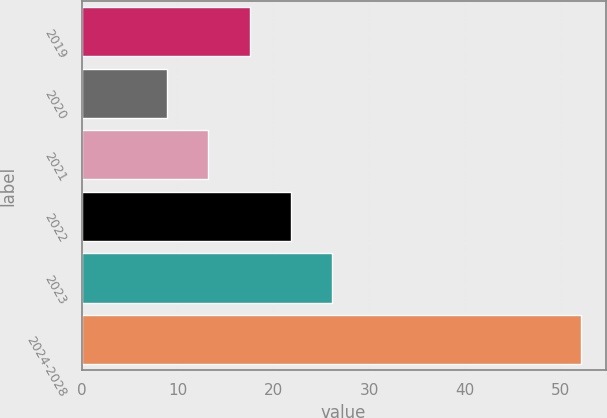<chart> <loc_0><loc_0><loc_500><loc_500><bar_chart><fcel>2019<fcel>2020<fcel>2021<fcel>2022<fcel>2023<fcel>2024-2028<nl><fcel>17.54<fcel>8.9<fcel>13.22<fcel>21.86<fcel>26.18<fcel>52.1<nl></chart> 